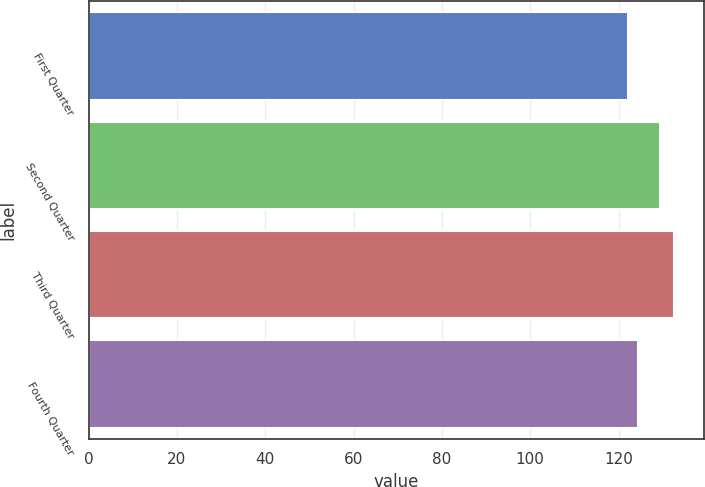Convert chart. <chart><loc_0><loc_0><loc_500><loc_500><bar_chart><fcel>First Quarter<fcel>Second Quarter<fcel>Third Quarter<fcel>Fourth Quarter<nl><fcel>122.11<fcel>129.39<fcel>132.61<fcel>124.46<nl></chart> 